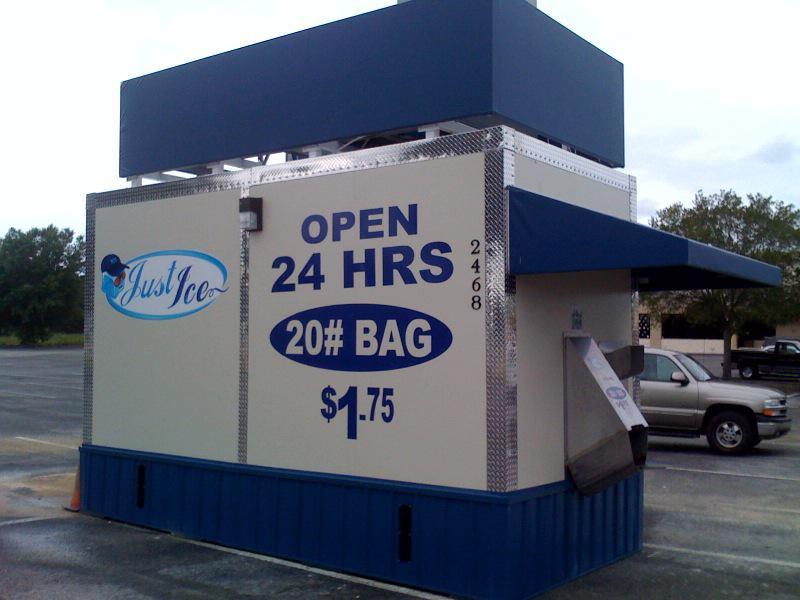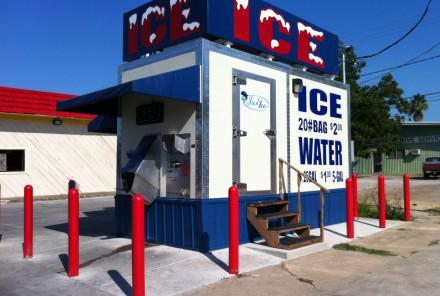The first image is the image on the left, the second image is the image on the right. For the images displayed, is the sentence "There are at least two painted penguins on the side of a ice house with blue trim." factually correct? Answer yes or no. No. The first image is the image on the left, the second image is the image on the right. Considering the images on both sides, is "A person is standing in front of one of the ice machines." valid? Answer yes or no. No. 